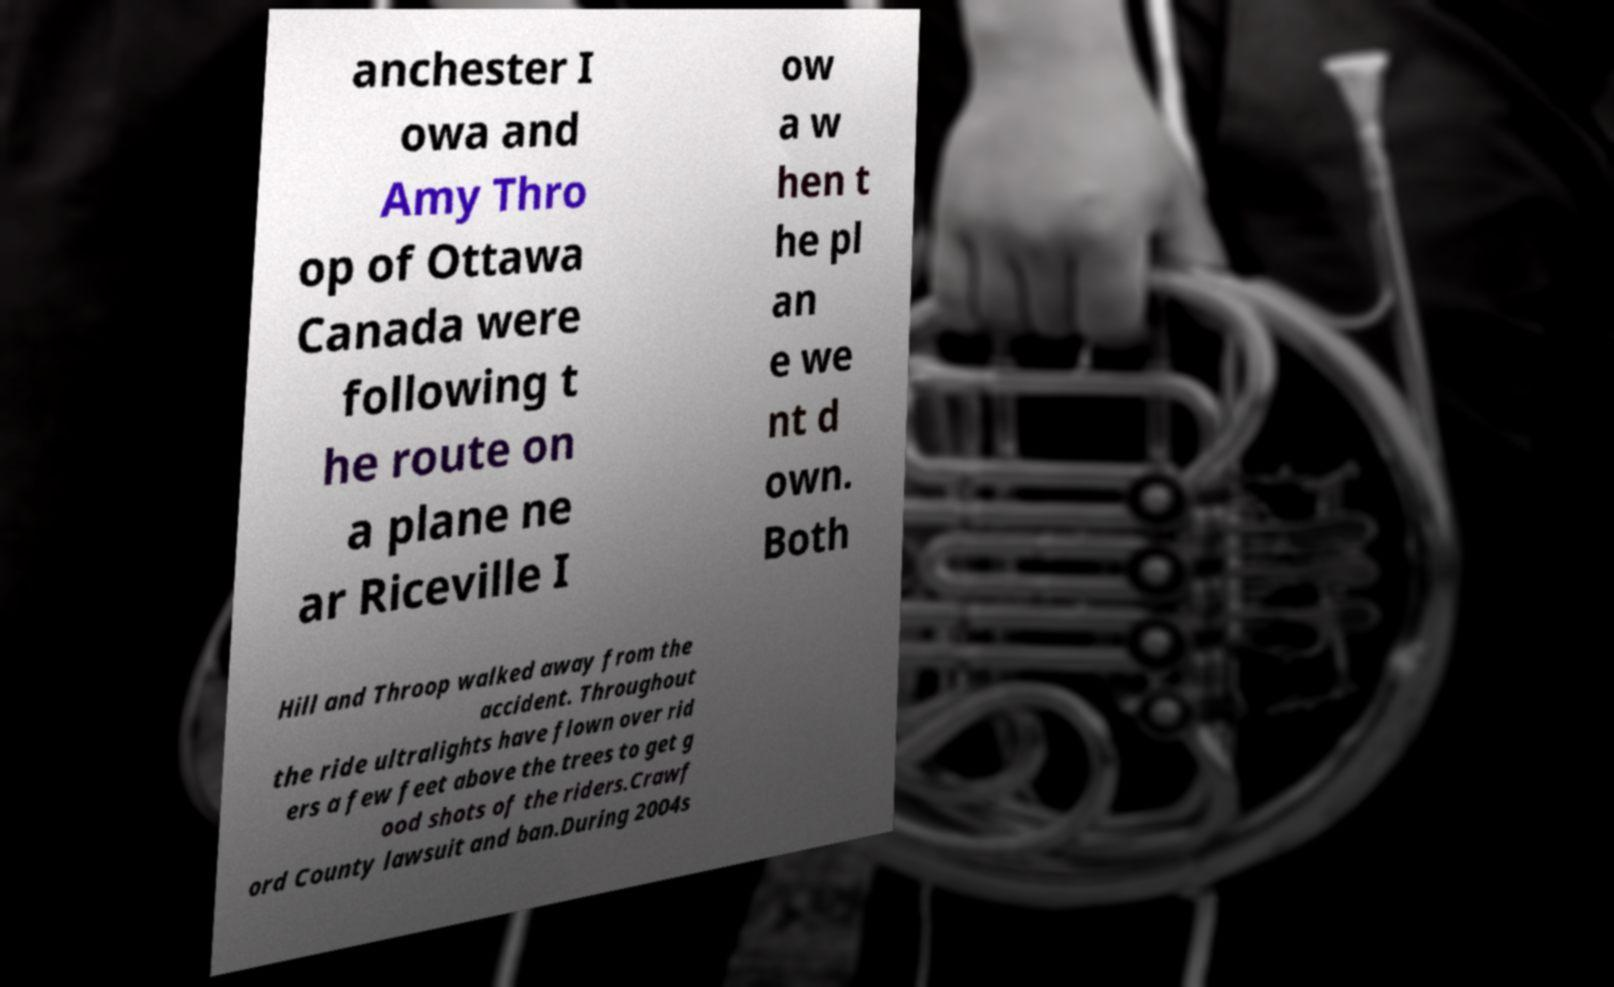Can you accurately transcribe the text from the provided image for me? anchester I owa and Amy Thro op of Ottawa Canada were following t he route on a plane ne ar Riceville I ow a w hen t he pl an e we nt d own. Both Hill and Throop walked away from the accident. Throughout the ride ultralights have flown over rid ers a few feet above the trees to get g ood shots of the riders.Crawf ord County lawsuit and ban.During 2004s 